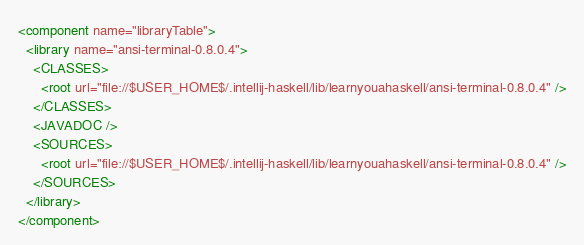Convert code to text. <code><loc_0><loc_0><loc_500><loc_500><_XML_><component name="libraryTable">
  <library name="ansi-terminal-0.8.0.4">
    <CLASSES>
      <root url="file://$USER_HOME$/.intellij-haskell/lib/learnyouahaskell/ansi-terminal-0.8.0.4" />
    </CLASSES>
    <JAVADOC />
    <SOURCES>
      <root url="file://$USER_HOME$/.intellij-haskell/lib/learnyouahaskell/ansi-terminal-0.8.0.4" />
    </SOURCES>
  </library>
</component></code> 